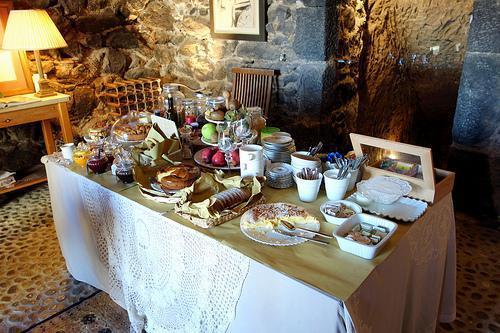How many pictures are hanging on the wall?
Give a very brief answer. 1. 